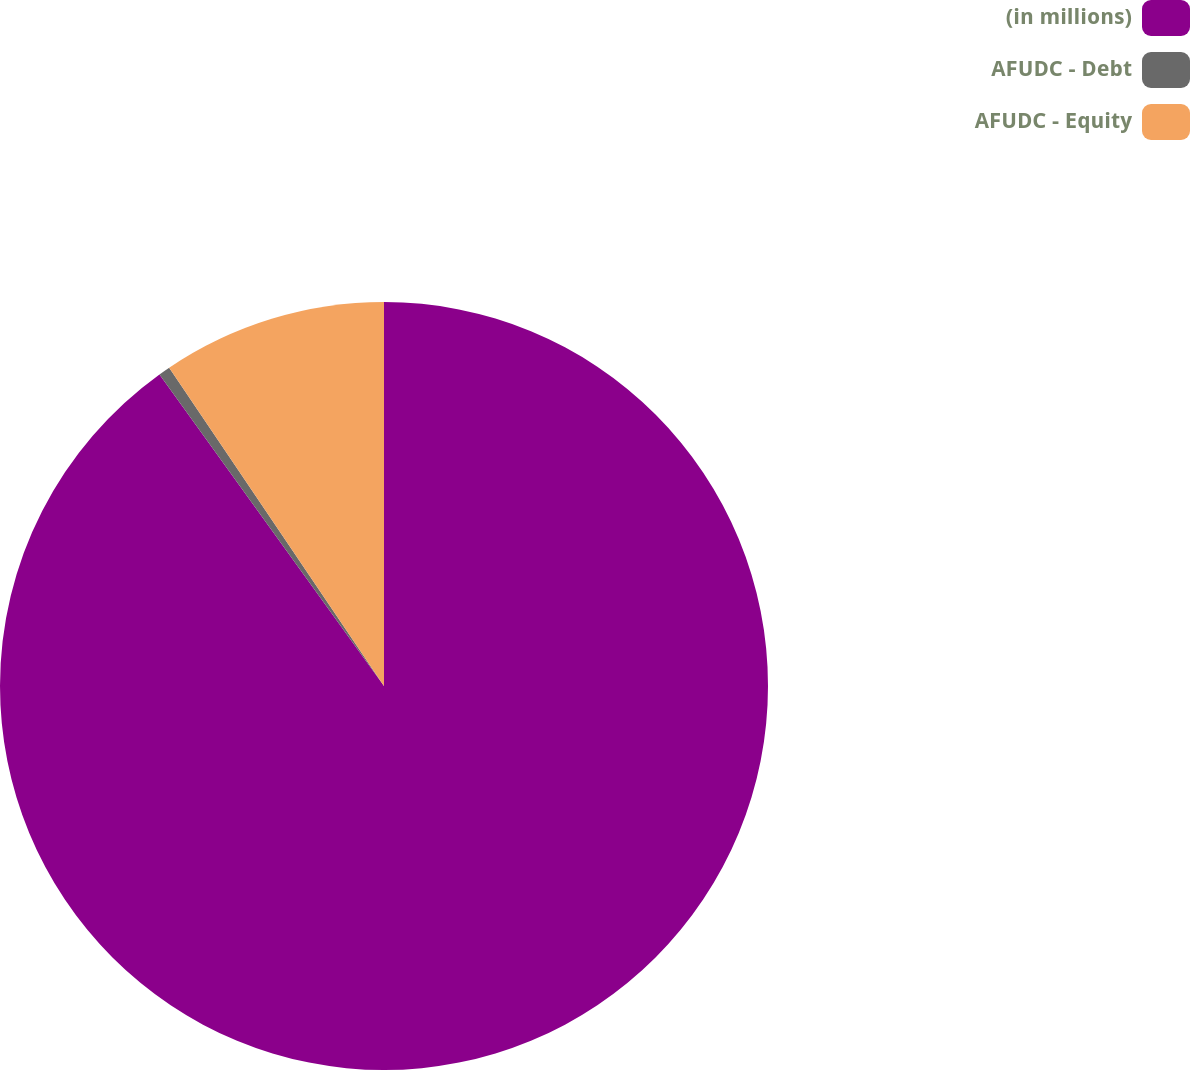<chart> <loc_0><loc_0><loc_500><loc_500><pie_chart><fcel>(in millions)<fcel>AFUDC - Debt<fcel>AFUDC - Equity<nl><fcel>90.07%<fcel>0.49%<fcel>9.45%<nl></chart> 